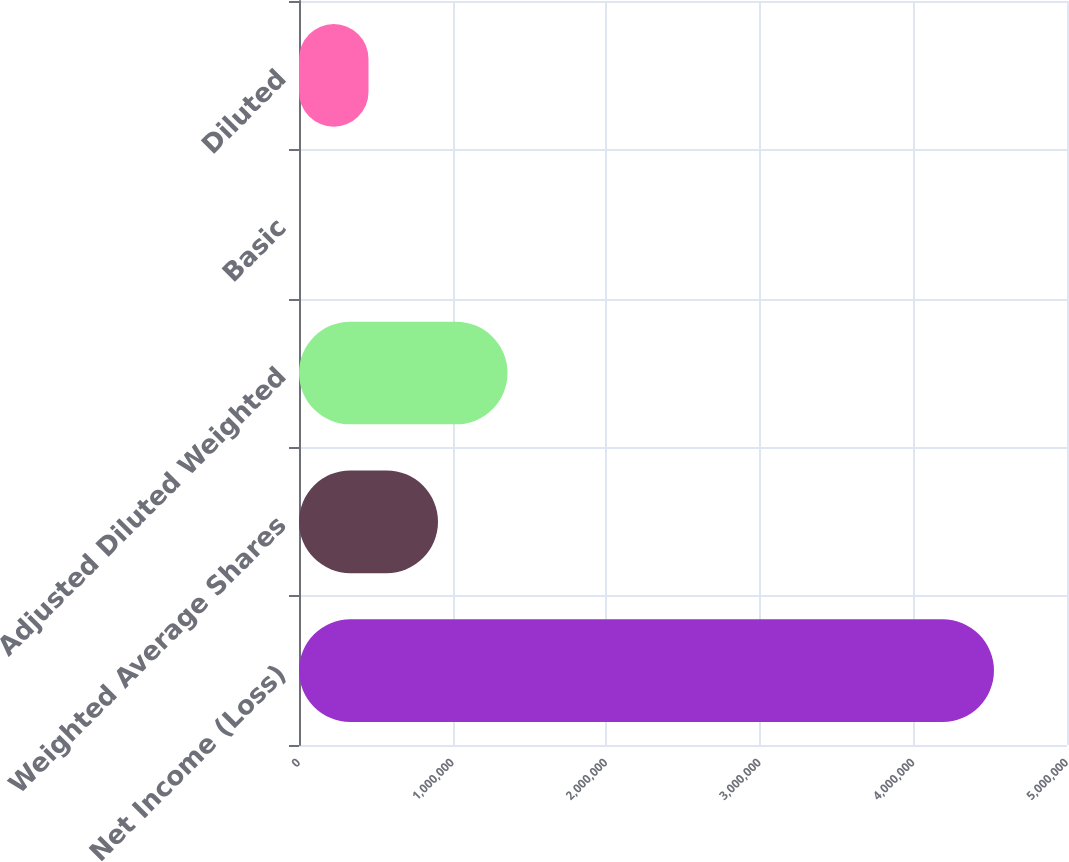Convert chart to OTSL. <chart><loc_0><loc_0><loc_500><loc_500><bar_chart><fcel>Net Income (Loss)<fcel>Weighted Average Shares<fcel>Adjusted Diluted Weighted<fcel>Basic<fcel>Diluted<nl><fcel>4.52452e+06<fcel>904910<fcel>1.35736e+06<fcel>8.29<fcel>452459<nl></chart> 